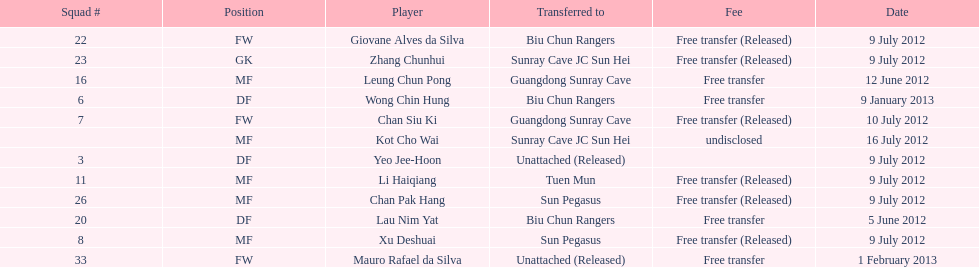What is the total number of players listed? 12. 